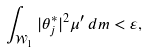Convert formula to latex. <formula><loc_0><loc_0><loc_500><loc_500>\int _ { \mathcal { W } _ { 1 } } | \theta _ { j } ^ { * } | ^ { 2 } \mu ^ { \prime } \, d m < \varepsilon ,</formula> 